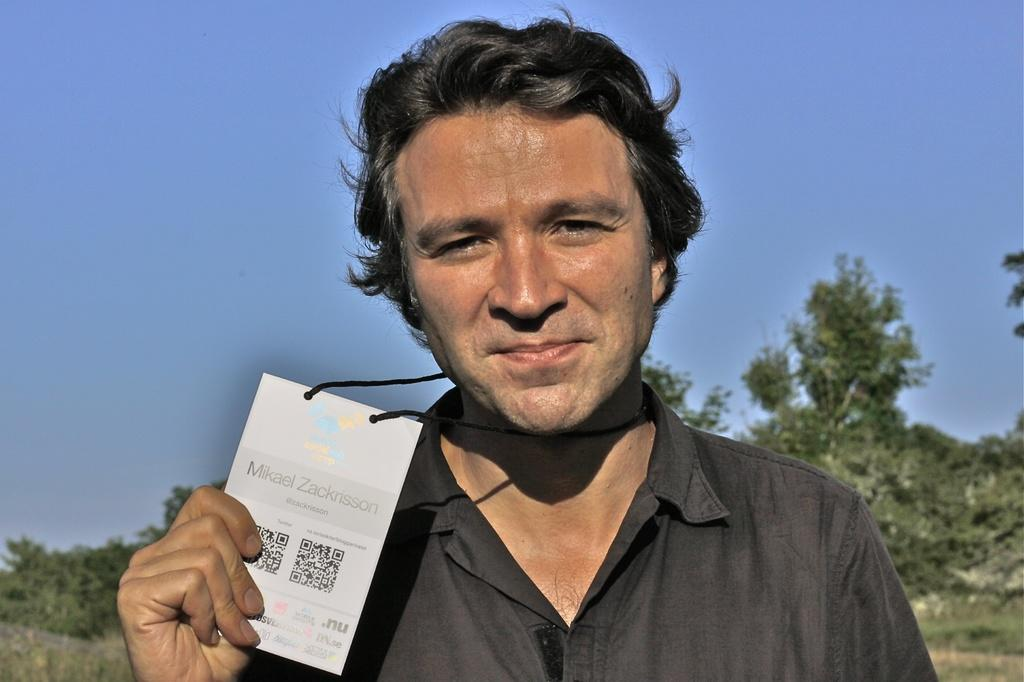What is present in the image? There is a man in the image. What is the man holding in his hand? The man is holding an object in his hand. What is the man wearing? The man is wearing a black shirt. What can be seen in the background of the image? There is sky and trees visible in the background of the image. What word is written on the man's shirt in the image? The man's shirt is described as black, but there is no mention of any words or text on it. 